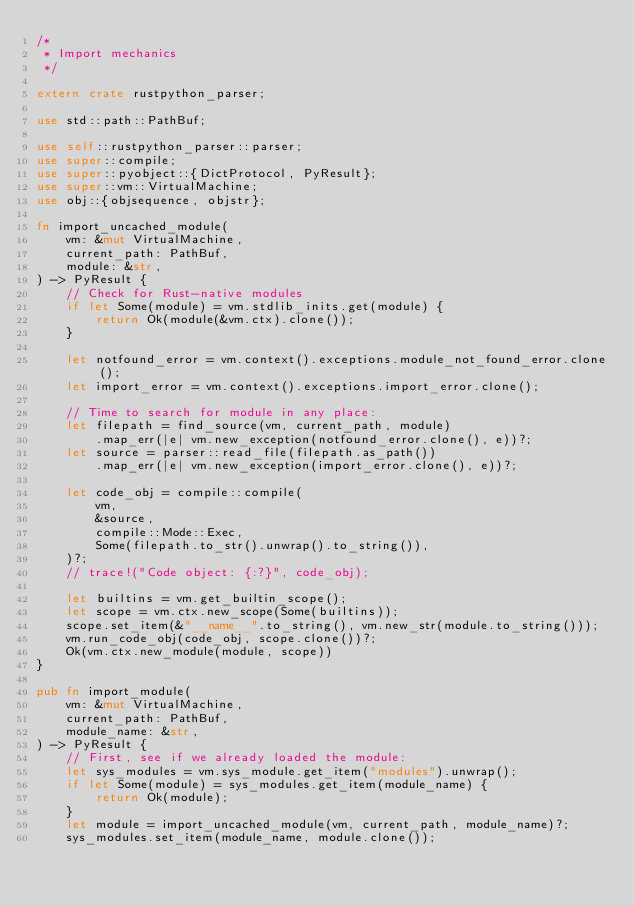Convert code to text. <code><loc_0><loc_0><loc_500><loc_500><_Rust_>/*
 * Import mechanics
 */

extern crate rustpython_parser;

use std::path::PathBuf;

use self::rustpython_parser::parser;
use super::compile;
use super::pyobject::{DictProtocol, PyResult};
use super::vm::VirtualMachine;
use obj::{objsequence, objstr};

fn import_uncached_module(
    vm: &mut VirtualMachine,
    current_path: PathBuf,
    module: &str,
) -> PyResult {
    // Check for Rust-native modules
    if let Some(module) = vm.stdlib_inits.get(module) {
        return Ok(module(&vm.ctx).clone());
    }

    let notfound_error = vm.context().exceptions.module_not_found_error.clone();
    let import_error = vm.context().exceptions.import_error.clone();

    // Time to search for module in any place:
    let filepath = find_source(vm, current_path, module)
        .map_err(|e| vm.new_exception(notfound_error.clone(), e))?;
    let source = parser::read_file(filepath.as_path())
        .map_err(|e| vm.new_exception(import_error.clone(), e))?;

    let code_obj = compile::compile(
        vm,
        &source,
        compile::Mode::Exec,
        Some(filepath.to_str().unwrap().to_string()),
    )?;
    // trace!("Code object: {:?}", code_obj);

    let builtins = vm.get_builtin_scope();
    let scope = vm.ctx.new_scope(Some(builtins));
    scope.set_item(&"__name__".to_string(), vm.new_str(module.to_string()));
    vm.run_code_obj(code_obj, scope.clone())?;
    Ok(vm.ctx.new_module(module, scope))
}

pub fn import_module(
    vm: &mut VirtualMachine,
    current_path: PathBuf,
    module_name: &str,
) -> PyResult {
    // First, see if we already loaded the module:
    let sys_modules = vm.sys_module.get_item("modules").unwrap();
    if let Some(module) = sys_modules.get_item(module_name) {
        return Ok(module);
    }
    let module = import_uncached_module(vm, current_path, module_name)?;
    sys_modules.set_item(module_name, module.clone());</code> 